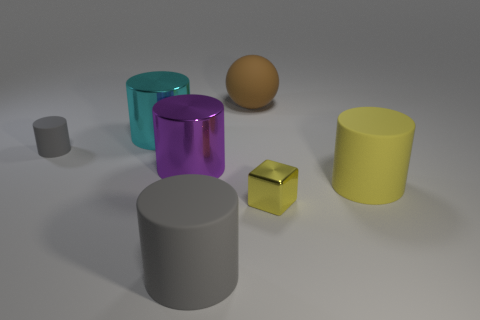What might be the function of the objects? Based on their simple geometric shapes, the objects could be placeholders or models used in a rendering software for visualization, educational, or design purposes. 